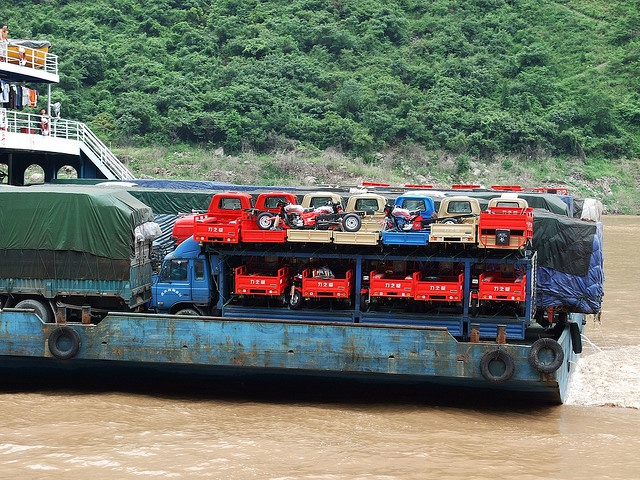Describe the objects in this image and their specific colors. I can see boat in teal, black, gray, and white tones, truck in teal, black, navy, red, and blue tones, truck in teal, black, and darkgreen tones, truck in teal, red, brown, salmon, and gray tones, and truck in teal, red, black, salmon, and white tones in this image. 